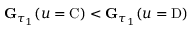Convert formula to latex. <formula><loc_0><loc_0><loc_500><loc_500>G _ { \tau _ { 1 } } ( u = C ) < G _ { \tau _ { 1 } } ( u = D )</formula> 